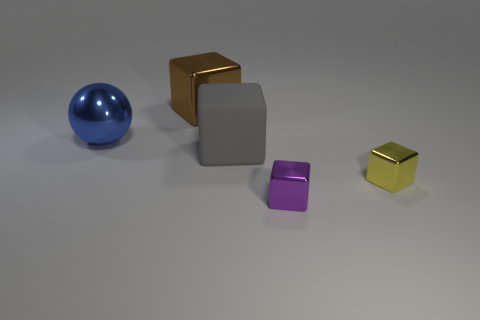Subtract 1 blocks. How many blocks are left? 3 Add 3 tiny objects. How many objects exist? 8 Subtract all spheres. How many objects are left? 4 Add 1 small yellow things. How many small yellow things exist? 2 Subtract 0 cyan cylinders. How many objects are left? 5 Subtract all matte things. Subtract all yellow things. How many objects are left? 3 Add 5 large blue balls. How many large blue balls are left? 6 